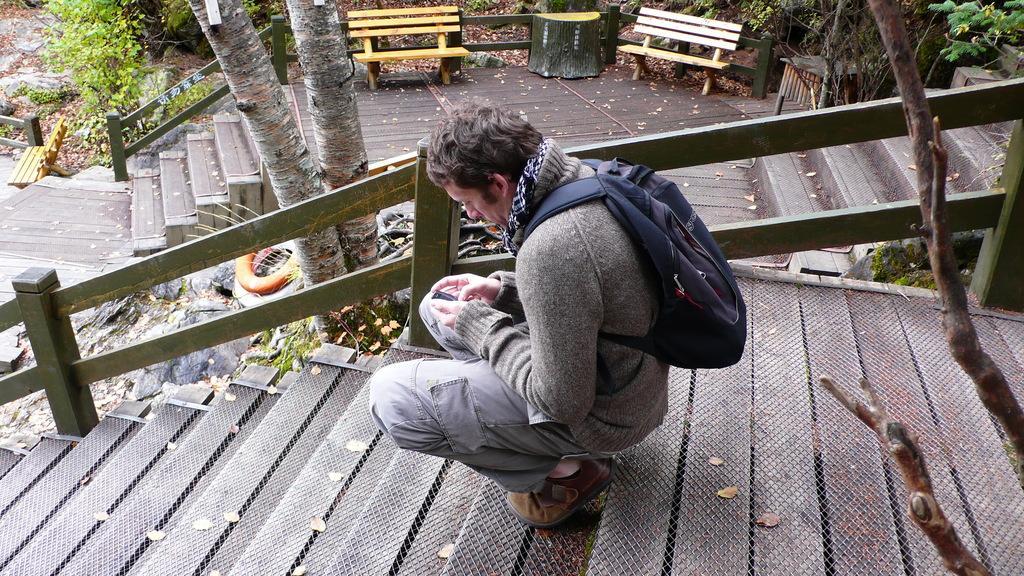Could you give a brief overview of what you see in this image? There is a man sitting like squat position and carrying a bag and holding a mobile. We can see steps, branches and railing. In the background we can see tree, branches and plants. 